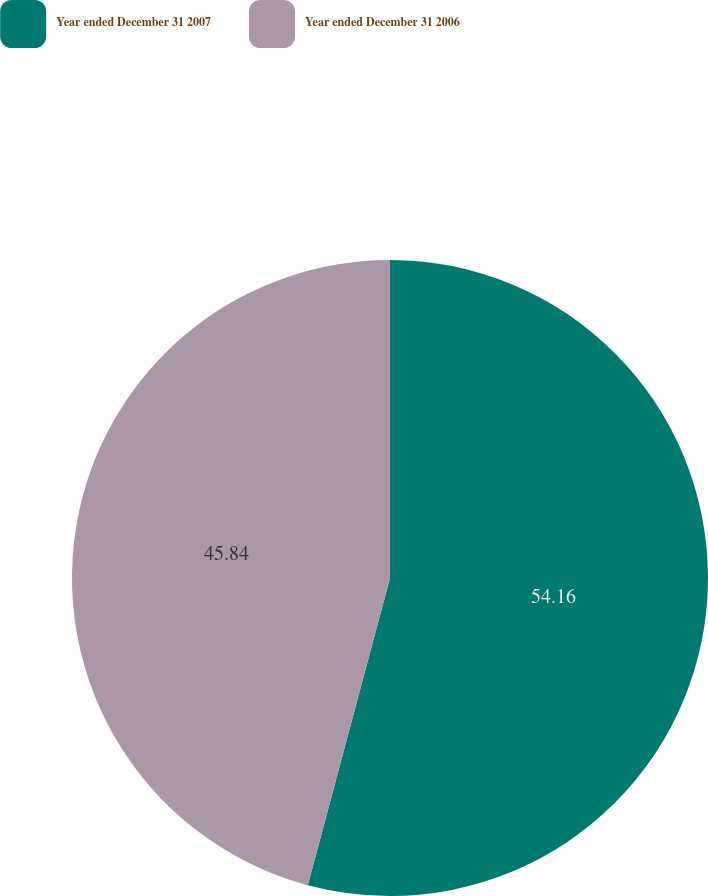<chart> <loc_0><loc_0><loc_500><loc_500><pie_chart><fcel>Year ended December 31 2007<fcel>Year ended December 31 2006<nl><fcel>54.16%<fcel>45.84%<nl></chart> 